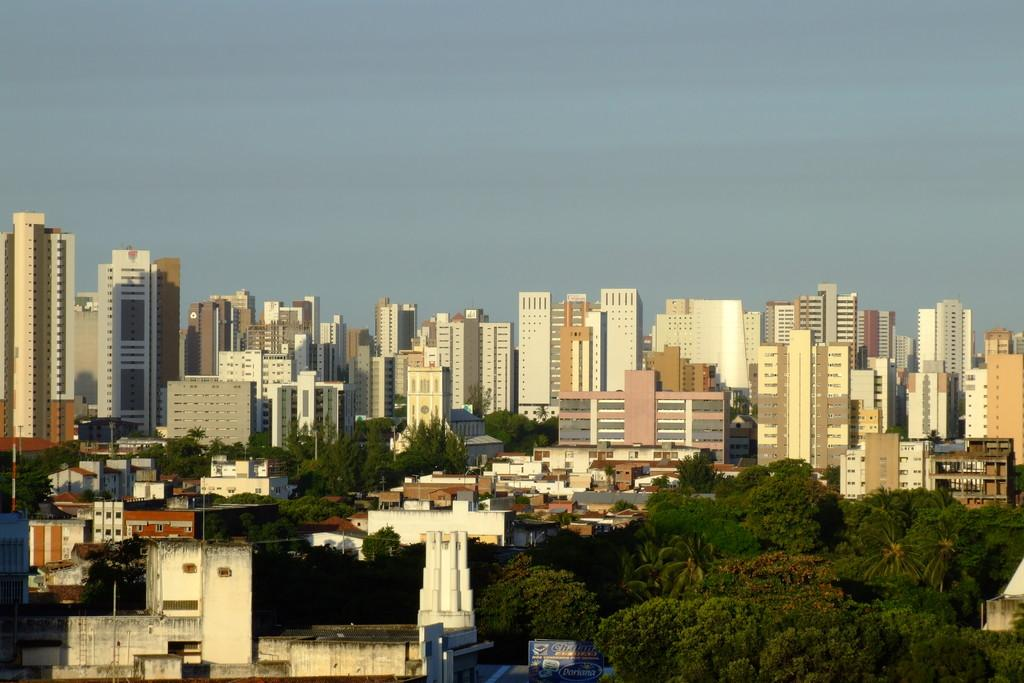What type of vegetation can be seen in the image? There are trees in the image. What is the color of the trees? The trees are green. What type of structures are present in the image? There are buildings in the image. What colors are the buildings? The buildings are in cream, white, and brown colors. What is visible in the background of the image? The sky is visible in the background of the image. What color is the sky? The sky is blue. What page is the achiever turning in the image? There is no reference to a page or an achiever in the image; it features trees and buildings with a blue sky in the background. What type of bucket is being used to collect water from the buildings? There is no bucket present in the image, and the buildings are not depicted as sources of water. 